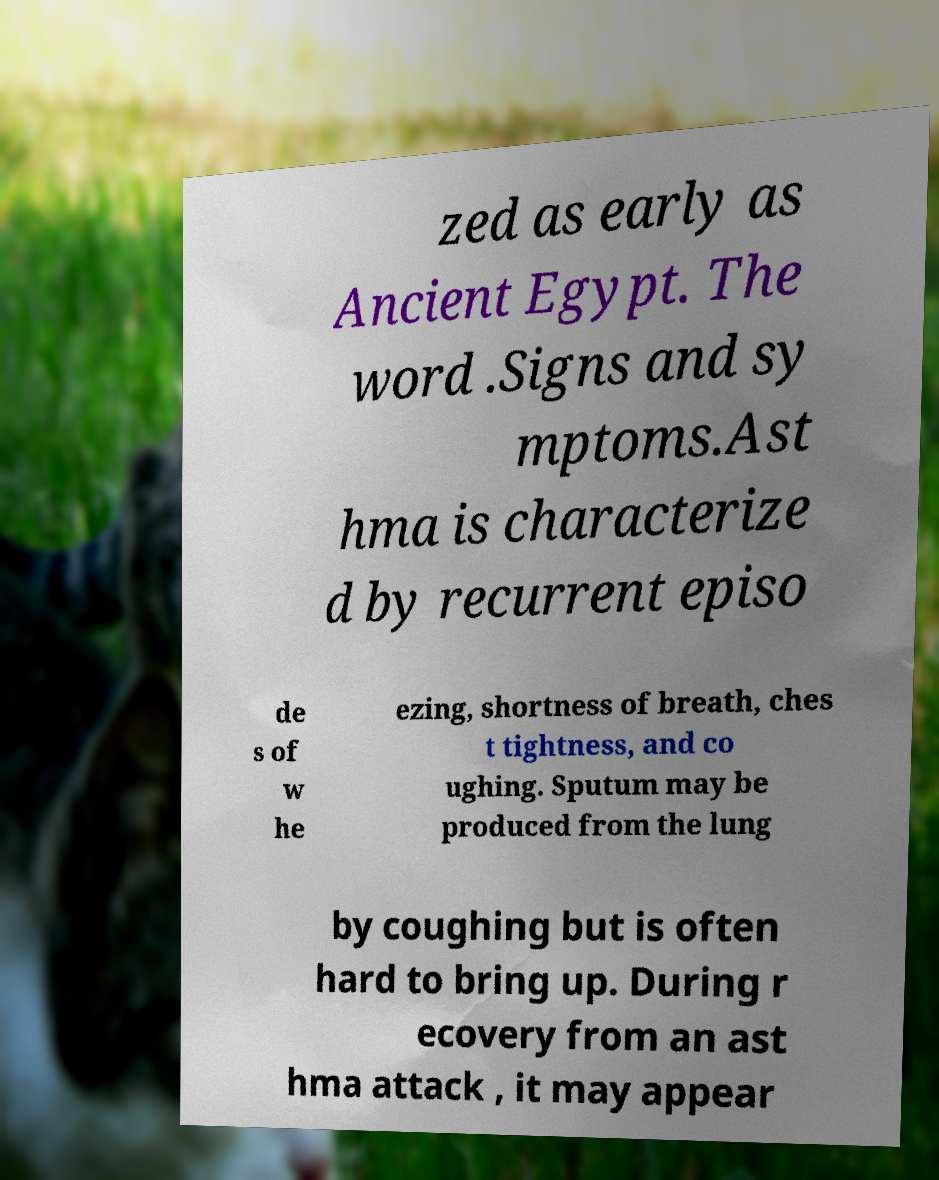Please read and relay the text visible in this image. What does it say? zed as early as Ancient Egypt. The word .Signs and sy mptoms.Ast hma is characterize d by recurrent episo de s of w he ezing, shortness of breath, ches t tightness, and co ughing. Sputum may be produced from the lung by coughing but is often hard to bring up. During r ecovery from an ast hma attack , it may appear 